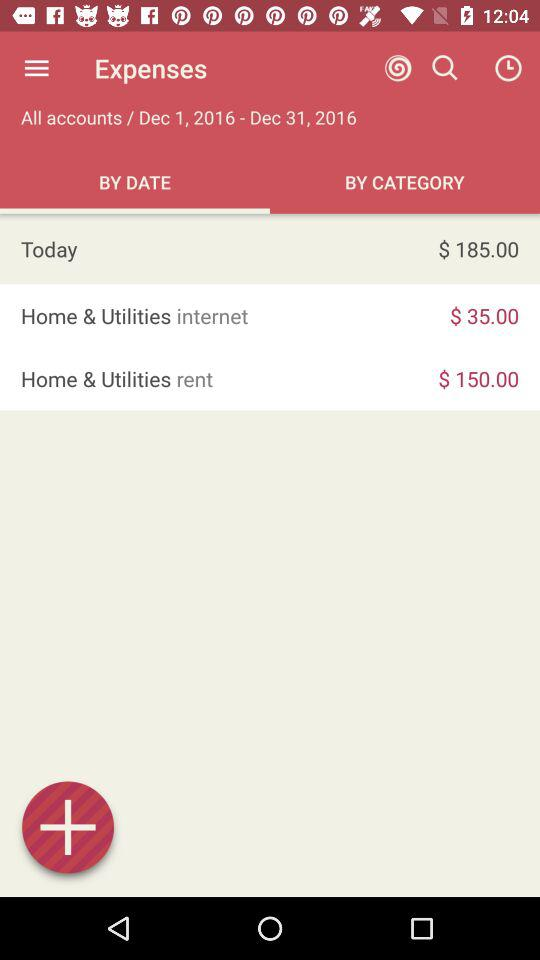What is the rent amount? The rent amount is $150. 